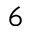<formula> <loc_0><loc_0><loc_500><loc_500>^ { 6 }</formula> 